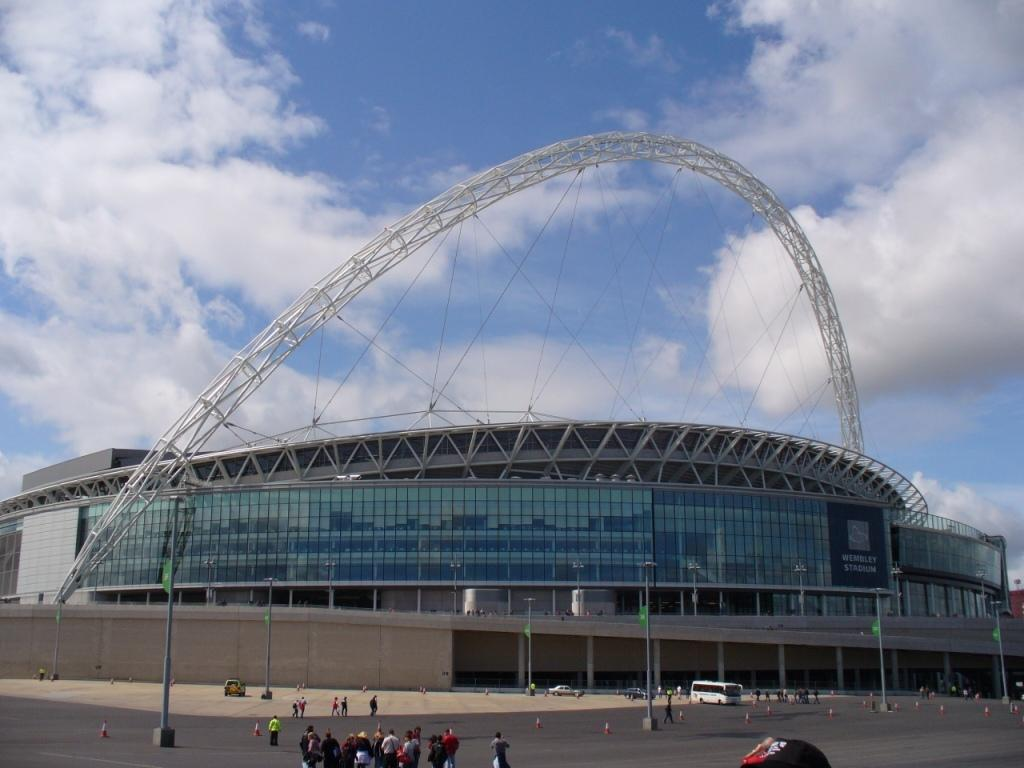What type of structure is visible in the image? There is an architectural building in the image. What is located in front of the building? There are poles, people, and vehicles in front of the building. What can be seen in the background of the image? The sky is visible behind the building. Can you see a woman saying good-bye to someone in the image? There is no woman or good-bye gesture visible in the image. What type of cup is being used by the people in the image? There is no cup present in the image. 